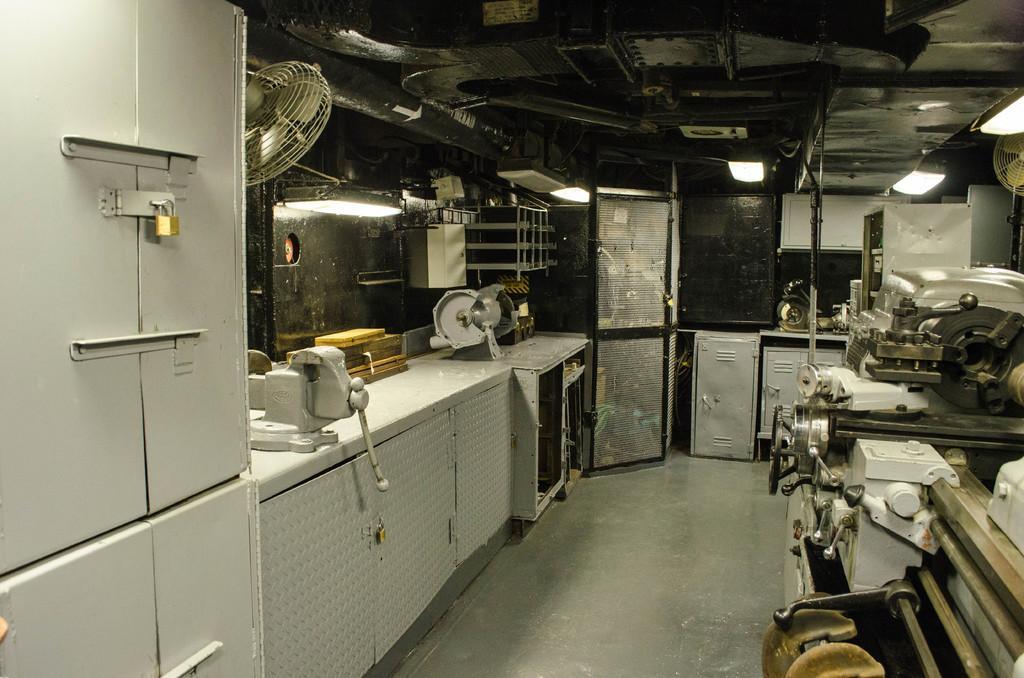How would you summarize this image in a sentence or two? In this picture I can see a table on which I can see some machines. Here I can see a table fan. On the right side I can see a table some machines. In the background I can see a door, lights on the ceiling. Here I can see cupboards. 